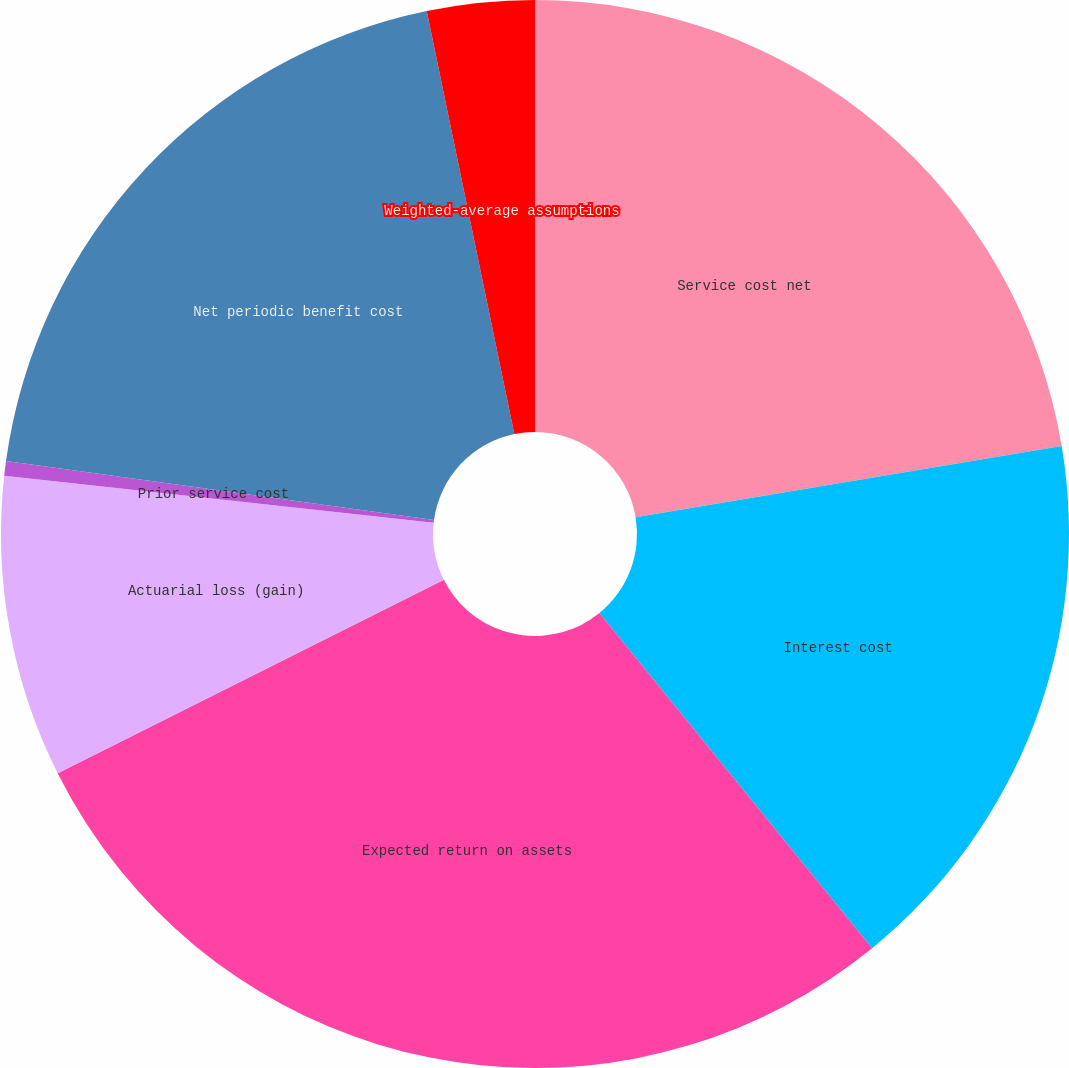Convert chart. <chart><loc_0><loc_0><loc_500><loc_500><pie_chart><fcel>Service cost net<fcel>Interest cost<fcel>Expected return on assets<fcel>Actuarial loss (gain)<fcel>Prior service cost<fcel>Net periodic benefit cost<fcel>Weighted-average assumptions<nl><fcel>22.37%<fcel>16.76%<fcel>28.48%<fcel>9.14%<fcel>0.44%<fcel>19.57%<fcel>3.25%<nl></chart> 